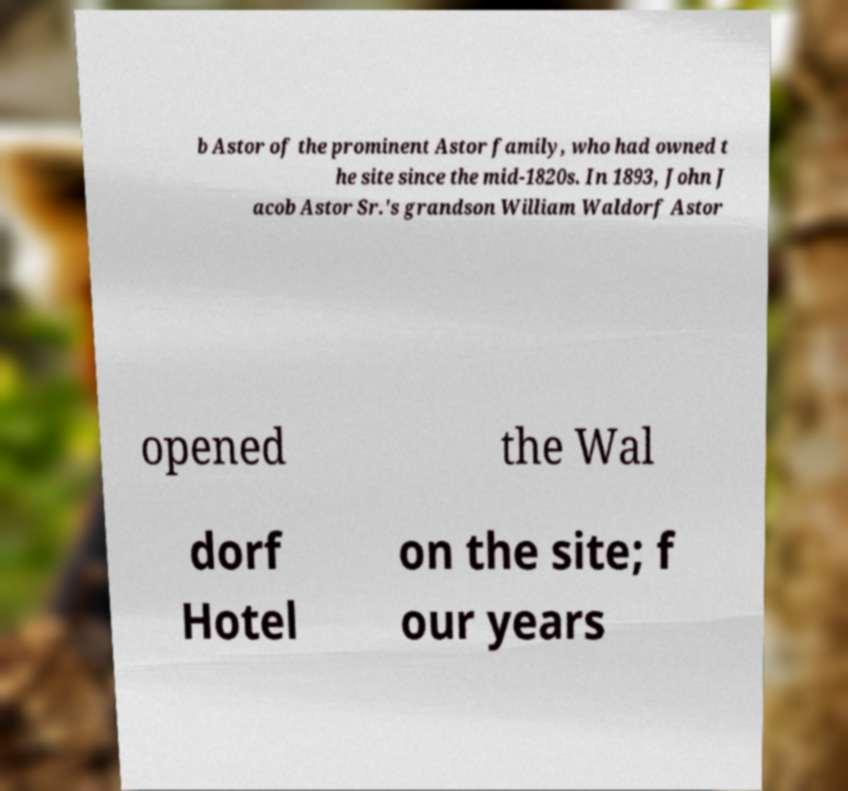I need the written content from this picture converted into text. Can you do that? b Astor of the prominent Astor family, who had owned t he site since the mid-1820s. In 1893, John J acob Astor Sr.'s grandson William Waldorf Astor opened the Wal dorf Hotel on the site; f our years 